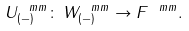<formula> <loc_0><loc_0><loc_500><loc_500>U ^ { \ m m } _ { ( - ) } \colon \, W ^ { \ m m } _ { ( - ) } \rightarrow F ^ { \ m m } .</formula> 